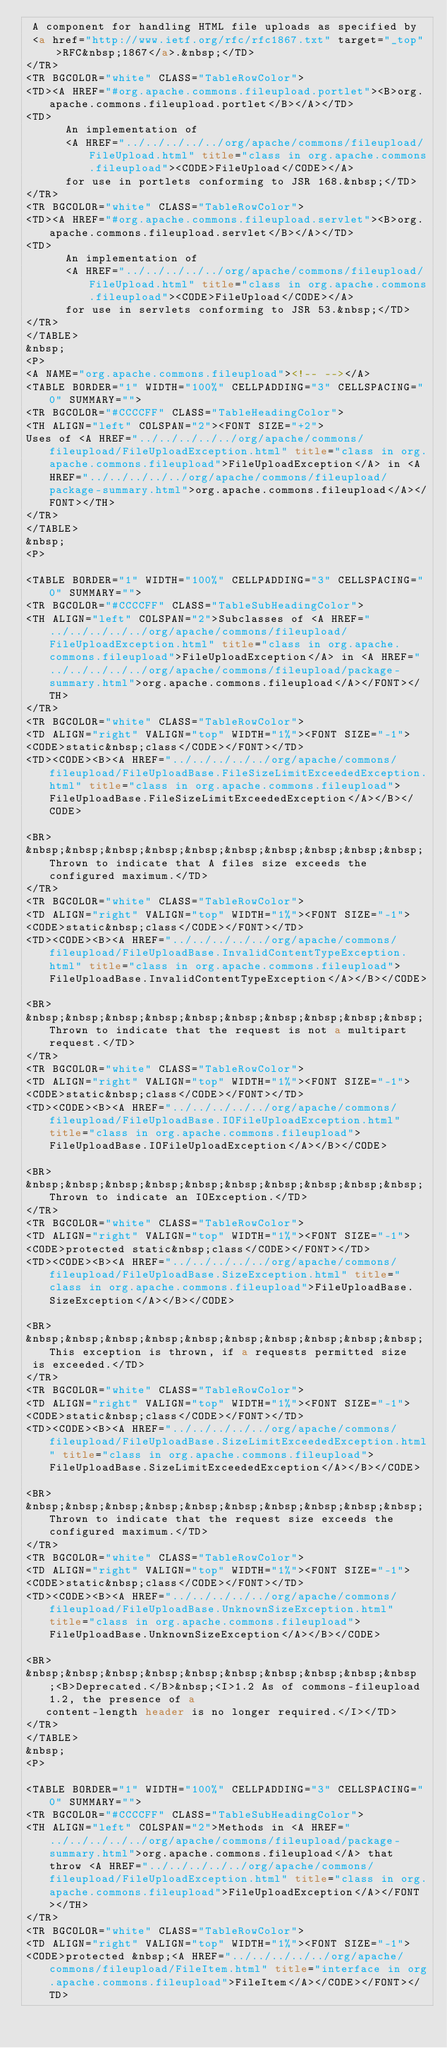Convert code to text. <code><loc_0><loc_0><loc_500><loc_500><_HTML_> A component for handling HTML file uploads as specified by
 <a href="http://www.ietf.org/rfc/rfc1867.txt" target="_top">RFC&nbsp;1867</a>.&nbsp;</TD>
</TR>
<TR BGCOLOR="white" CLASS="TableRowColor">
<TD><A HREF="#org.apache.commons.fileupload.portlet"><B>org.apache.commons.fileupload.portlet</B></A></TD>
<TD>
      An implementation of
      <A HREF="../../../../../org/apache/commons/fileupload/FileUpload.html" title="class in org.apache.commons.fileupload"><CODE>FileUpload</CODE></A>
      for use in portlets conforming to JSR 168.&nbsp;</TD>
</TR>
<TR BGCOLOR="white" CLASS="TableRowColor">
<TD><A HREF="#org.apache.commons.fileupload.servlet"><B>org.apache.commons.fileupload.servlet</B></A></TD>
<TD>
      An implementation of
      <A HREF="../../../../../org/apache/commons/fileupload/FileUpload.html" title="class in org.apache.commons.fileupload"><CODE>FileUpload</CODE></A>
      for use in servlets conforming to JSR 53.&nbsp;</TD>
</TR>
</TABLE>
&nbsp;
<P>
<A NAME="org.apache.commons.fileupload"><!-- --></A>
<TABLE BORDER="1" WIDTH="100%" CELLPADDING="3" CELLSPACING="0" SUMMARY="">
<TR BGCOLOR="#CCCCFF" CLASS="TableHeadingColor">
<TH ALIGN="left" COLSPAN="2"><FONT SIZE="+2">
Uses of <A HREF="../../../../../org/apache/commons/fileupload/FileUploadException.html" title="class in org.apache.commons.fileupload">FileUploadException</A> in <A HREF="../../../../../org/apache/commons/fileupload/package-summary.html">org.apache.commons.fileupload</A></FONT></TH>
</TR>
</TABLE>
&nbsp;
<P>

<TABLE BORDER="1" WIDTH="100%" CELLPADDING="3" CELLSPACING="0" SUMMARY="">
<TR BGCOLOR="#CCCCFF" CLASS="TableSubHeadingColor">
<TH ALIGN="left" COLSPAN="2">Subclasses of <A HREF="../../../../../org/apache/commons/fileupload/FileUploadException.html" title="class in org.apache.commons.fileupload">FileUploadException</A> in <A HREF="../../../../../org/apache/commons/fileupload/package-summary.html">org.apache.commons.fileupload</A></FONT></TH>
</TR>
<TR BGCOLOR="white" CLASS="TableRowColor">
<TD ALIGN="right" VALIGN="top" WIDTH="1%"><FONT SIZE="-1">
<CODE>static&nbsp;class</CODE></FONT></TD>
<TD><CODE><B><A HREF="../../../../../org/apache/commons/fileupload/FileUploadBase.FileSizeLimitExceededException.html" title="class in org.apache.commons.fileupload">FileUploadBase.FileSizeLimitExceededException</A></B></CODE>

<BR>
&nbsp;&nbsp;&nbsp;&nbsp;&nbsp;&nbsp;&nbsp;&nbsp;&nbsp;&nbsp;Thrown to indicate that A files size exceeds the configured maximum.</TD>
</TR>
<TR BGCOLOR="white" CLASS="TableRowColor">
<TD ALIGN="right" VALIGN="top" WIDTH="1%"><FONT SIZE="-1">
<CODE>static&nbsp;class</CODE></FONT></TD>
<TD><CODE><B><A HREF="../../../../../org/apache/commons/fileupload/FileUploadBase.InvalidContentTypeException.html" title="class in org.apache.commons.fileupload">FileUploadBase.InvalidContentTypeException</A></B></CODE>

<BR>
&nbsp;&nbsp;&nbsp;&nbsp;&nbsp;&nbsp;&nbsp;&nbsp;&nbsp;&nbsp;Thrown to indicate that the request is not a multipart request.</TD>
</TR>
<TR BGCOLOR="white" CLASS="TableRowColor">
<TD ALIGN="right" VALIGN="top" WIDTH="1%"><FONT SIZE="-1">
<CODE>static&nbsp;class</CODE></FONT></TD>
<TD><CODE><B><A HREF="../../../../../org/apache/commons/fileupload/FileUploadBase.IOFileUploadException.html" title="class in org.apache.commons.fileupload">FileUploadBase.IOFileUploadException</A></B></CODE>

<BR>
&nbsp;&nbsp;&nbsp;&nbsp;&nbsp;&nbsp;&nbsp;&nbsp;&nbsp;&nbsp;Thrown to indicate an IOException.</TD>
</TR>
<TR BGCOLOR="white" CLASS="TableRowColor">
<TD ALIGN="right" VALIGN="top" WIDTH="1%"><FONT SIZE="-1">
<CODE>protected static&nbsp;class</CODE></FONT></TD>
<TD><CODE><B><A HREF="../../../../../org/apache/commons/fileupload/FileUploadBase.SizeException.html" title="class in org.apache.commons.fileupload">FileUploadBase.SizeException</A></B></CODE>

<BR>
&nbsp;&nbsp;&nbsp;&nbsp;&nbsp;&nbsp;&nbsp;&nbsp;&nbsp;&nbsp;This exception is thrown, if a requests permitted size
 is exceeded.</TD>
</TR>
<TR BGCOLOR="white" CLASS="TableRowColor">
<TD ALIGN="right" VALIGN="top" WIDTH="1%"><FONT SIZE="-1">
<CODE>static&nbsp;class</CODE></FONT></TD>
<TD><CODE><B><A HREF="../../../../../org/apache/commons/fileupload/FileUploadBase.SizeLimitExceededException.html" title="class in org.apache.commons.fileupload">FileUploadBase.SizeLimitExceededException</A></B></CODE>

<BR>
&nbsp;&nbsp;&nbsp;&nbsp;&nbsp;&nbsp;&nbsp;&nbsp;&nbsp;&nbsp;Thrown to indicate that the request size exceeds the configured maximum.</TD>
</TR>
<TR BGCOLOR="white" CLASS="TableRowColor">
<TD ALIGN="right" VALIGN="top" WIDTH="1%"><FONT SIZE="-1">
<CODE>static&nbsp;class</CODE></FONT></TD>
<TD><CODE><B><A HREF="../../../../../org/apache/commons/fileupload/FileUploadBase.UnknownSizeException.html" title="class in org.apache.commons.fileupload">FileUploadBase.UnknownSizeException</A></B></CODE>

<BR>
&nbsp;&nbsp;&nbsp;&nbsp;&nbsp;&nbsp;&nbsp;&nbsp;&nbsp;&nbsp;<B>Deprecated.</B>&nbsp;<I>1.2 As of commons-fileupload 1.2, the presence of a
   content-length header is no longer required.</I></TD>
</TR>
</TABLE>
&nbsp;
<P>

<TABLE BORDER="1" WIDTH="100%" CELLPADDING="3" CELLSPACING="0" SUMMARY="">
<TR BGCOLOR="#CCCCFF" CLASS="TableSubHeadingColor">
<TH ALIGN="left" COLSPAN="2">Methods in <A HREF="../../../../../org/apache/commons/fileupload/package-summary.html">org.apache.commons.fileupload</A> that throw <A HREF="../../../../../org/apache/commons/fileupload/FileUploadException.html" title="class in org.apache.commons.fileupload">FileUploadException</A></FONT></TH>
</TR>
<TR BGCOLOR="white" CLASS="TableRowColor">
<TD ALIGN="right" VALIGN="top" WIDTH="1%"><FONT SIZE="-1">
<CODE>protected &nbsp;<A HREF="../../../../../org/apache/commons/fileupload/FileItem.html" title="interface in org.apache.commons.fileupload">FileItem</A></CODE></FONT></TD></code> 